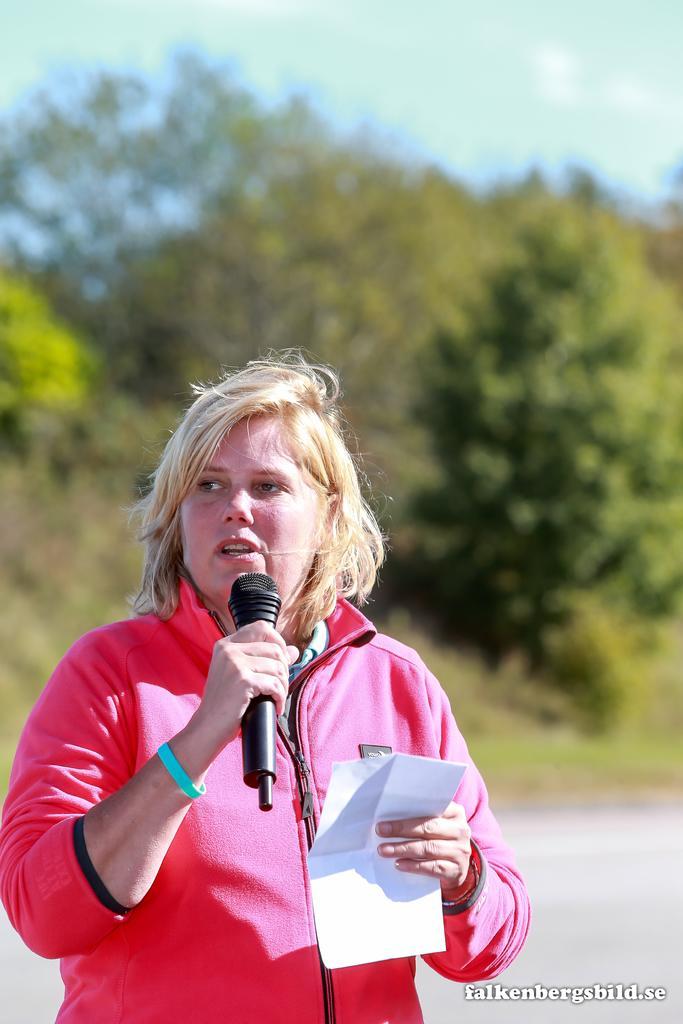Describe this image in one or two sentences. This picture is of outside. In the foreground there is a woman wearing red color jacket, holding a paper in one hand and a microphone in another hand, standing and seems to be talking. In the background we can see the sky, trees and grass. There is a watermark on the image. 